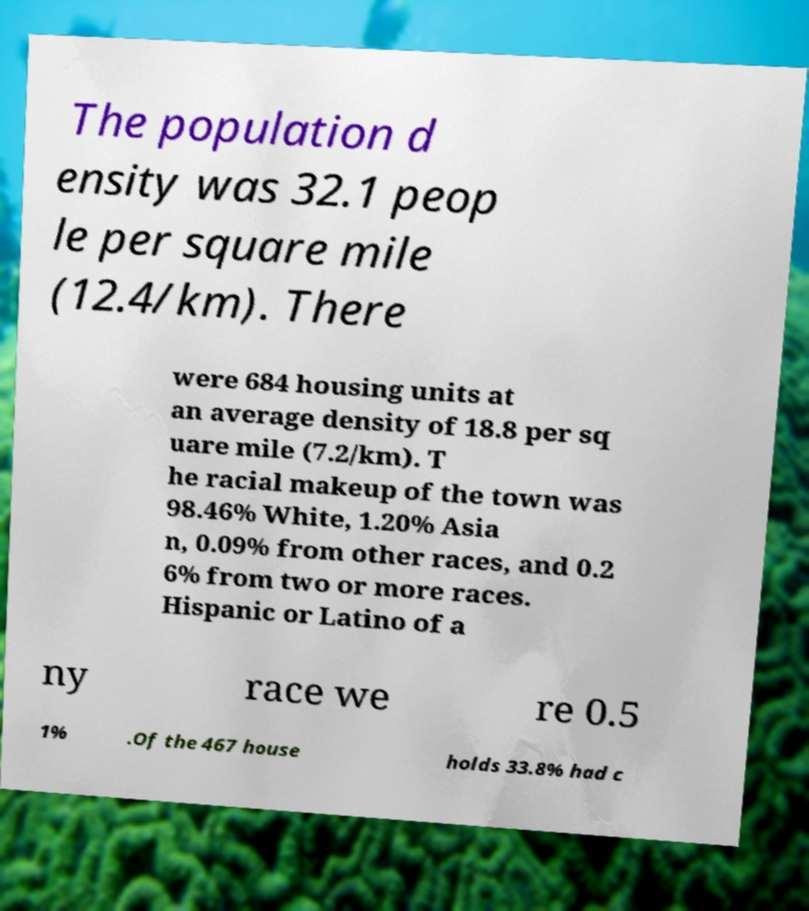What messages or text are displayed in this image? I need them in a readable, typed format. The population d ensity was 32.1 peop le per square mile (12.4/km). There were 684 housing units at an average density of 18.8 per sq uare mile (7.2/km). T he racial makeup of the town was 98.46% White, 1.20% Asia n, 0.09% from other races, and 0.2 6% from two or more races. Hispanic or Latino of a ny race we re 0.5 1% .Of the 467 house holds 33.8% had c 